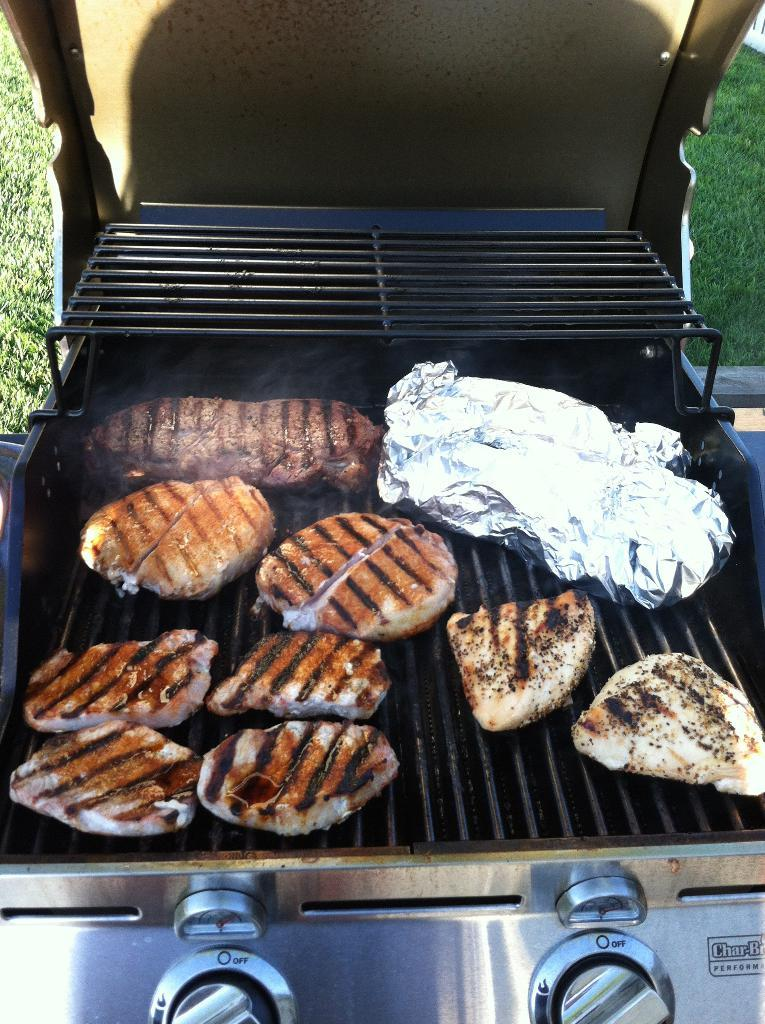What is the main object in the image? There is a grill in the image. What is on the grill? Bread pieces are on the grill. Are there any controls on the grill? Yes, there are two buttons at the bottom of the grill. What can be seen in the background of the image? There is grass in the background of the image. How is the grill positioned in the image? The grill appears to be part of a stove that is opened. How many times does the bell ring during the week in the image? There is no bell present in the image, so it is not possible to determine how many times it rings during the week. 